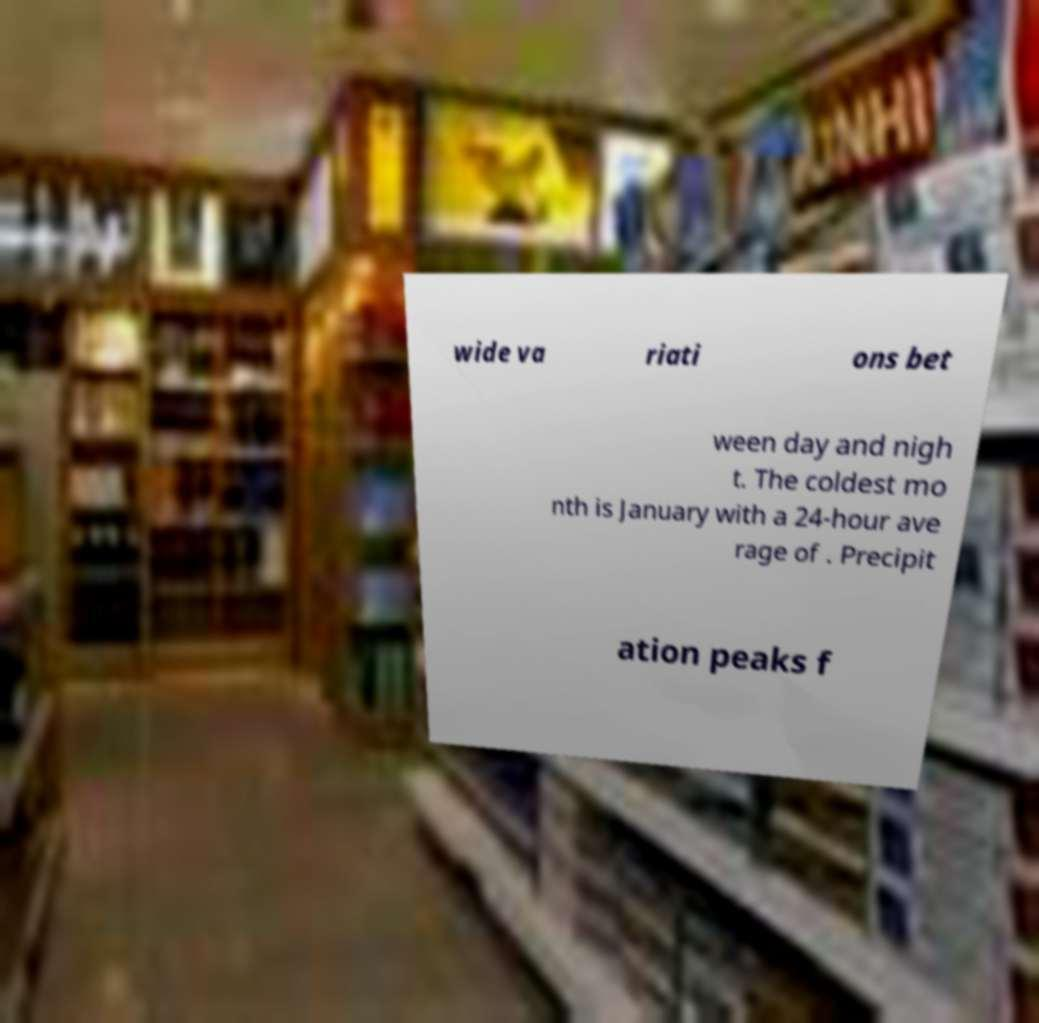Please identify and transcribe the text found in this image. wide va riati ons bet ween day and nigh t. The coldest mo nth is January with a 24-hour ave rage of . Precipit ation peaks f 